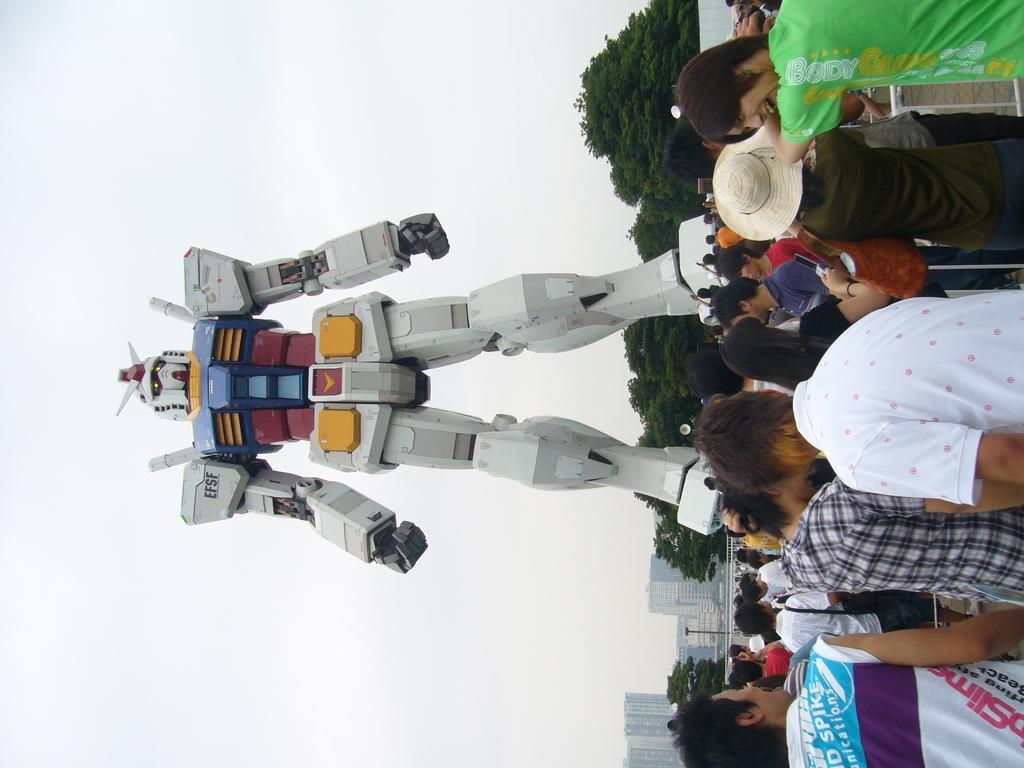What is the main subject in the image? There is a robot in the image. What can be seen behind the robot? There is a group of trees behind the robot. What is visible in the background of the image? There are buildings and the sky visible in the image. Where are the persons located in the image? There is a group of persons on the right side of the image. What book is the robot reading in the image? There is no book or reading activity depicted in the image; the robot is the main subject. 